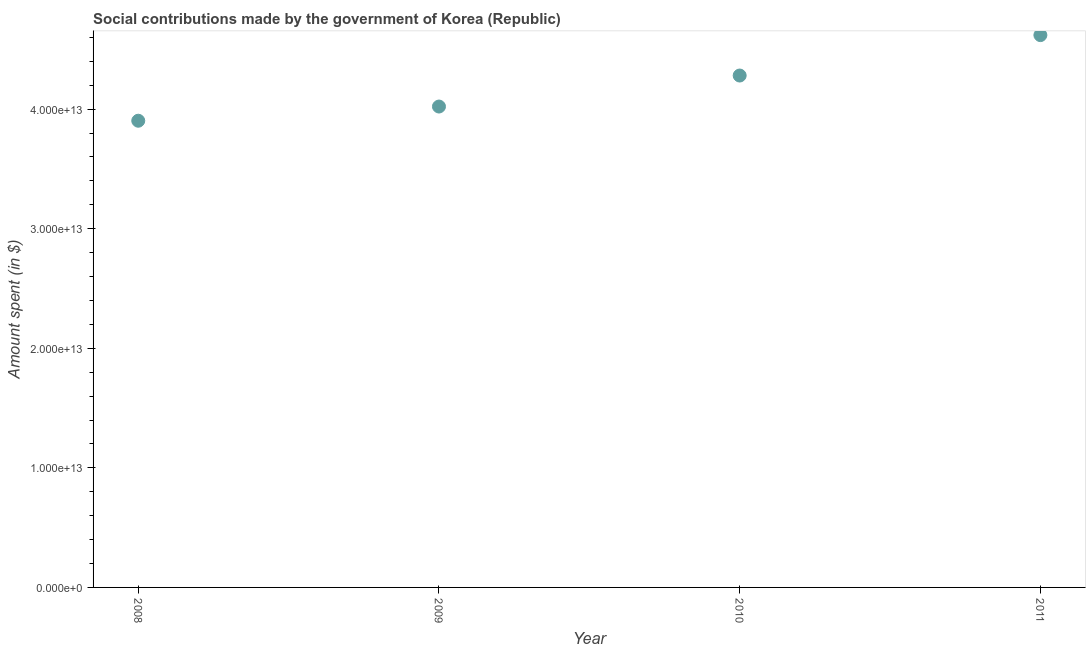What is the amount spent in making social contributions in 2010?
Your response must be concise. 4.28e+13. Across all years, what is the maximum amount spent in making social contributions?
Give a very brief answer. 4.62e+13. Across all years, what is the minimum amount spent in making social contributions?
Provide a short and direct response. 3.90e+13. In which year was the amount spent in making social contributions maximum?
Offer a very short reply. 2011. What is the sum of the amount spent in making social contributions?
Provide a short and direct response. 1.68e+14. What is the difference between the amount spent in making social contributions in 2010 and 2011?
Provide a succinct answer. -3.38e+12. What is the average amount spent in making social contributions per year?
Give a very brief answer. 4.21e+13. What is the median amount spent in making social contributions?
Provide a short and direct response. 4.15e+13. Do a majority of the years between 2011 and 2008 (inclusive) have amount spent in making social contributions greater than 24000000000000 $?
Your answer should be compact. Yes. What is the ratio of the amount spent in making social contributions in 2010 to that in 2011?
Ensure brevity in your answer.  0.93. Is the amount spent in making social contributions in 2009 less than that in 2011?
Your response must be concise. Yes. Is the difference between the amount spent in making social contributions in 2009 and 2010 greater than the difference between any two years?
Keep it short and to the point. No. What is the difference between the highest and the second highest amount spent in making social contributions?
Offer a terse response. 3.38e+12. What is the difference between the highest and the lowest amount spent in making social contributions?
Offer a terse response. 7.16e+12. In how many years, is the amount spent in making social contributions greater than the average amount spent in making social contributions taken over all years?
Provide a short and direct response. 2. What is the difference between two consecutive major ticks on the Y-axis?
Offer a terse response. 1.00e+13. Are the values on the major ticks of Y-axis written in scientific E-notation?
Keep it short and to the point. Yes. Does the graph contain any zero values?
Offer a very short reply. No. Does the graph contain grids?
Give a very brief answer. No. What is the title of the graph?
Make the answer very short. Social contributions made by the government of Korea (Republic). What is the label or title of the Y-axis?
Make the answer very short. Amount spent (in $). What is the Amount spent (in $) in 2008?
Your answer should be very brief. 3.90e+13. What is the Amount spent (in $) in 2009?
Your answer should be very brief. 4.02e+13. What is the Amount spent (in $) in 2010?
Your answer should be compact. 4.28e+13. What is the Amount spent (in $) in 2011?
Provide a short and direct response. 4.62e+13. What is the difference between the Amount spent (in $) in 2008 and 2009?
Your response must be concise. -1.19e+12. What is the difference between the Amount spent (in $) in 2008 and 2010?
Ensure brevity in your answer.  -3.78e+12. What is the difference between the Amount spent (in $) in 2008 and 2011?
Your answer should be compact. -7.16e+12. What is the difference between the Amount spent (in $) in 2009 and 2010?
Provide a succinct answer. -2.59e+12. What is the difference between the Amount spent (in $) in 2009 and 2011?
Your response must be concise. -5.97e+12. What is the difference between the Amount spent (in $) in 2010 and 2011?
Make the answer very short. -3.38e+12. What is the ratio of the Amount spent (in $) in 2008 to that in 2010?
Your response must be concise. 0.91. What is the ratio of the Amount spent (in $) in 2008 to that in 2011?
Make the answer very short. 0.84. What is the ratio of the Amount spent (in $) in 2009 to that in 2010?
Provide a succinct answer. 0.94. What is the ratio of the Amount spent (in $) in 2009 to that in 2011?
Give a very brief answer. 0.87. What is the ratio of the Amount spent (in $) in 2010 to that in 2011?
Your answer should be compact. 0.93. 